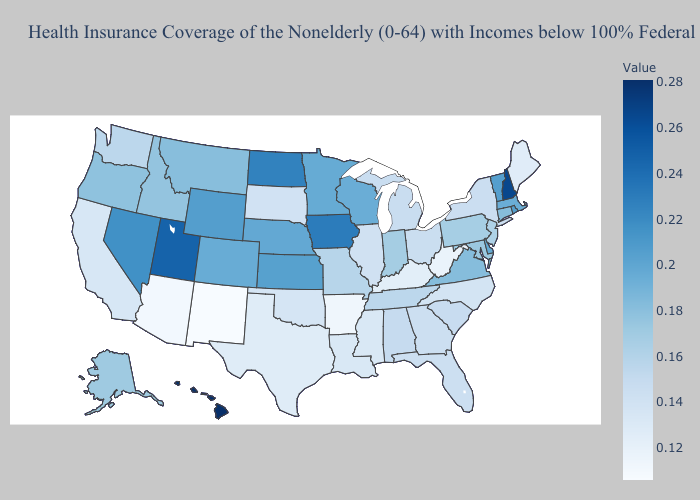Does Maine have the lowest value in the USA?
Quick response, please. No. Is the legend a continuous bar?
Answer briefly. Yes. Which states hav the highest value in the MidWest?
Quick response, please. Iowa. 